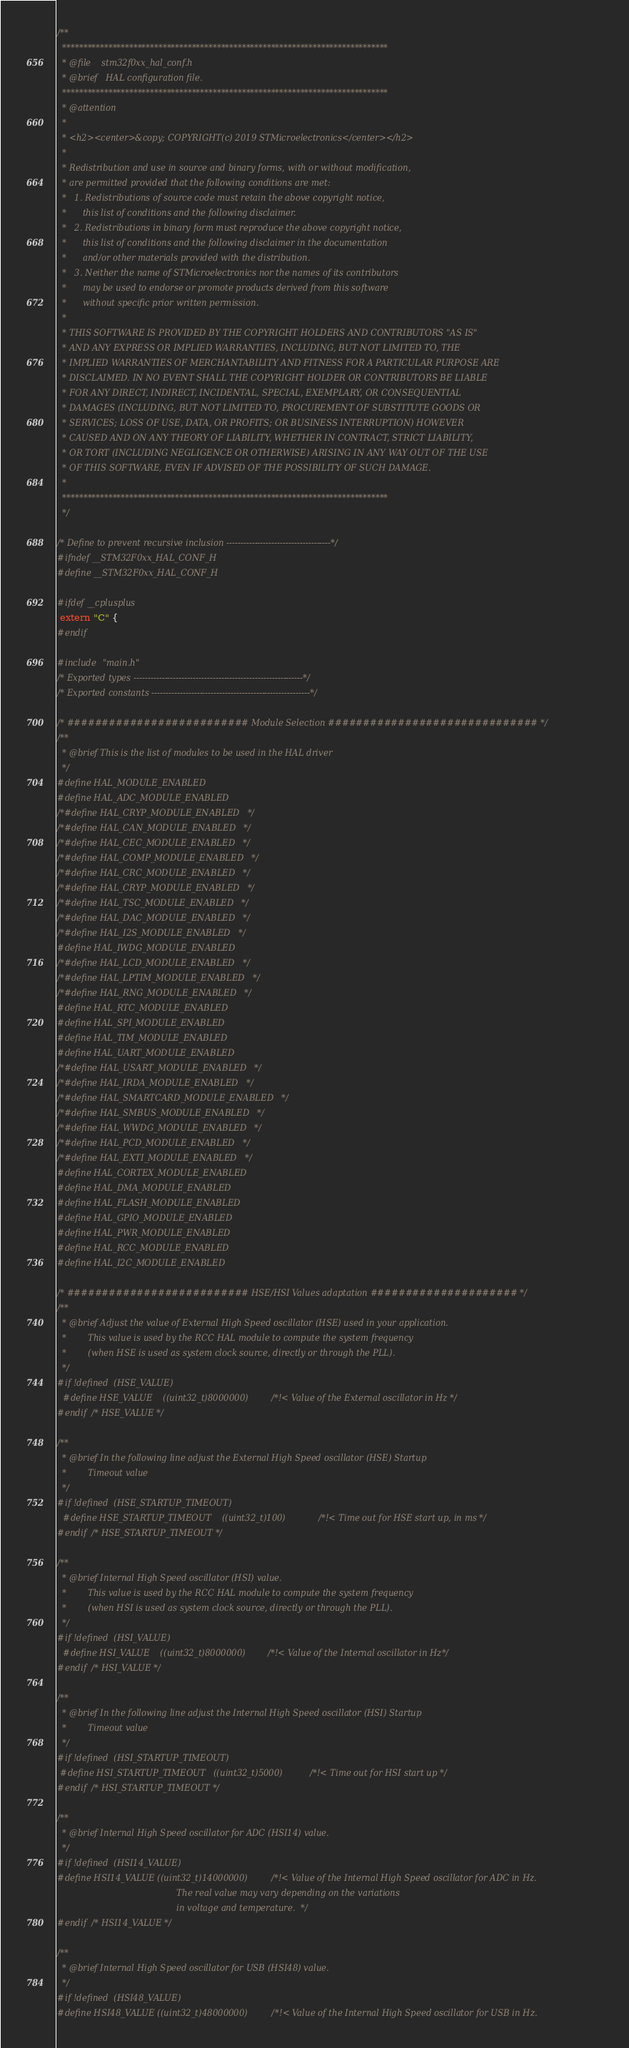Convert code to text. <code><loc_0><loc_0><loc_500><loc_500><_C_>/**
  ******************************************************************************
  * @file    stm32f0xx_hal_conf.h
  * @brief   HAL configuration file.
  ******************************************************************************
  * @attention
  *
  * <h2><center>&copy; COPYRIGHT(c) 2019 STMicroelectronics</center></h2>
  *
  * Redistribution and use in source and binary forms, with or without modification,
  * are permitted provided that the following conditions are met:
  *   1. Redistributions of source code must retain the above copyright notice,
  *      this list of conditions and the following disclaimer.
  *   2. Redistributions in binary form must reproduce the above copyright notice,
  *      this list of conditions and the following disclaimer in the documentation
  *      and/or other materials provided with the distribution.
  *   3. Neither the name of STMicroelectronics nor the names of its contributors
  *      may be used to endorse or promote products derived from this software
  *      without specific prior written permission.
  *
  * THIS SOFTWARE IS PROVIDED BY THE COPYRIGHT HOLDERS AND CONTRIBUTORS "AS IS"
  * AND ANY EXPRESS OR IMPLIED WARRANTIES, INCLUDING, BUT NOT LIMITED TO, THE
  * IMPLIED WARRANTIES OF MERCHANTABILITY AND FITNESS FOR A PARTICULAR PURPOSE ARE
  * DISCLAIMED. IN NO EVENT SHALL THE COPYRIGHT HOLDER OR CONTRIBUTORS BE LIABLE
  * FOR ANY DIRECT, INDIRECT, INCIDENTAL, SPECIAL, EXEMPLARY, OR CONSEQUENTIAL
  * DAMAGES (INCLUDING, BUT NOT LIMITED TO, PROCUREMENT OF SUBSTITUTE GOODS OR
  * SERVICES; LOSS OF USE, DATA, OR PROFITS; OR BUSINESS INTERRUPTION) HOWEVER
  * CAUSED AND ON ANY THEORY OF LIABILITY, WHETHER IN CONTRACT, STRICT LIABILITY,
  * OR TORT (INCLUDING NEGLIGENCE OR OTHERWISE) ARISING IN ANY WAY OUT OF THE USE
  * OF THIS SOFTWARE, EVEN IF ADVISED OF THE POSSIBILITY OF SUCH DAMAGE.
  *
  ******************************************************************************
  */ 

/* Define to prevent recursive inclusion -------------------------------------*/
#ifndef __STM32F0xx_HAL_CONF_H
#define __STM32F0xx_HAL_CONF_H

#ifdef __cplusplus
 extern "C" {
#endif

#include "main.h"
/* Exported types ------------------------------------------------------------*/
/* Exported constants --------------------------------------------------------*/

/* ########################## Module Selection ############################## */
/**
  * @brief This is the list of modules to be used in the HAL driver 
  */
#define HAL_MODULE_ENABLED  
#define HAL_ADC_MODULE_ENABLED
/*#define HAL_CRYP_MODULE_ENABLED   */
/*#define HAL_CAN_MODULE_ENABLED   */
/*#define HAL_CEC_MODULE_ENABLED   */
/*#define HAL_COMP_MODULE_ENABLED   */
/*#define HAL_CRC_MODULE_ENABLED   */
/*#define HAL_CRYP_MODULE_ENABLED   */
/*#define HAL_TSC_MODULE_ENABLED   */
/*#define HAL_DAC_MODULE_ENABLED   */
/*#define HAL_I2S_MODULE_ENABLED   */
#define HAL_IWDG_MODULE_ENABLED
/*#define HAL_LCD_MODULE_ENABLED   */
/*#define HAL_LPTIM_MODULE_ENABLED   */
/*#define HAL_RNG_MODULE_ENABLED   */
#define HAL_RTC_MODULE_ENABLED
#define HAL_SPI_MODULE_ENABLED
#define HAL_TIM_MODULE_ENABLED
#define HAL_UART_MODULE_ENABLED
/*#define HAL_USART_MODULE_ENABLED   */
/*#define HAL_IRDA_MODULE_ENABLED   */
/*#define HAL_SMARTCARD_MODULE_ENABLED   */
/*#define HAL_SMBUS_MODULE_ENABLED   */
/*#define HAL_WWDG_MODULE_ENABLED   */
/*#define HAL_PCD_MODULE_ENABLED   */
/*#define HAL_EXTI_MODULE_ENABLED   */
#define HAL_CORTEX_MODULE_ENABLED
#define HAL_DMA_MODULE_ENABLED
#define HAL_FLASH_MODULE_ENABLED
#define HAL_GPIO_MODULE_ENABLED
#define HAL_PWR_MODULE_ENABLED
#define HAL_RCC_MODULE_ENABLED
#define HAL_I2C_MODULE_ENABLED

/* ########################## HSE/HSI Values adaptation ##################### */
/**
  * @brief Adjust the value of External High Speed oscillator (HSE) used in your application.
  *        This value is used by the RCC HAL module to compute the system frequency
  *        (when HSE is used as system clock source, directly or through the PLL).  
  */
#if !defined  (HSE_VALUE) 
  #define HSE_VALUE    ((uint32_t)8000000) /*!< Value of the External oscillator in Hz */
#endif /* HSE_VALUE */

/**
  * @brief In the following line adjust the External High Speed oscillator (HSE) Startup 
  *        Timeout value 
  */
#if !defined  (HSE_STARTUP_TIMEOUT)
  #define HSE_STARTUP_TIMEOUT    ((uint32_t)100)   /*!< Time out for HSE start up, in ms */
#endif /* HSE_STARTUP_TIMEOUT */

/**
  * @brief Internal High Speed oscillator (HSI) value.
  *        This value is used by the RCC HAL module to compute the system frequency
  *        (when HSI is used as system clock source, directly or through the PLL). 
  */
#if !defined  (HSI_VALUE)
  #define HSI_VALUE    ((uint32_t)8000000) /*!< Value of the Internal oscillator in Hz*/
#endif /* HSI_VALUE */

/**
  * @brief In the following line adjust the Internal High Speed oscillator (HSI) Startup 
  *        Timeout value 
  */
#if !defined  (HSI_STARTUP_TIMEOUT) 
 #define HSI_STARTUP_TIMEOUT   ((uint32_t)5000) /*!< Time out for HSI start up */
#endif /* HSI_STARTUP_TIMEOUT */  

/**
  * @brief Internal High Speed oscillator for ADC (HSI14) value.
  */
#if !defined  (HSI14_VALUE) 
#define HSI14_VALUE ((uint32_t)14000000) /*!< Value of the Internal High Speed oscillator for ADC in Hz.
                                             The real value may vary depending on the variations
                                             in voltage and temperature.  */
#endif /* HSI14_VALUE */

/**
  * @brief Internal High Speed oscillator for USB (HSI48) value.
  */
#if !defined  (HSI48_VALUE) 
#define HSI48_VALUE ((uint32_t)48000000) /*!< Value of the Internal High Speed oscillator for USB in Hz.</code> 